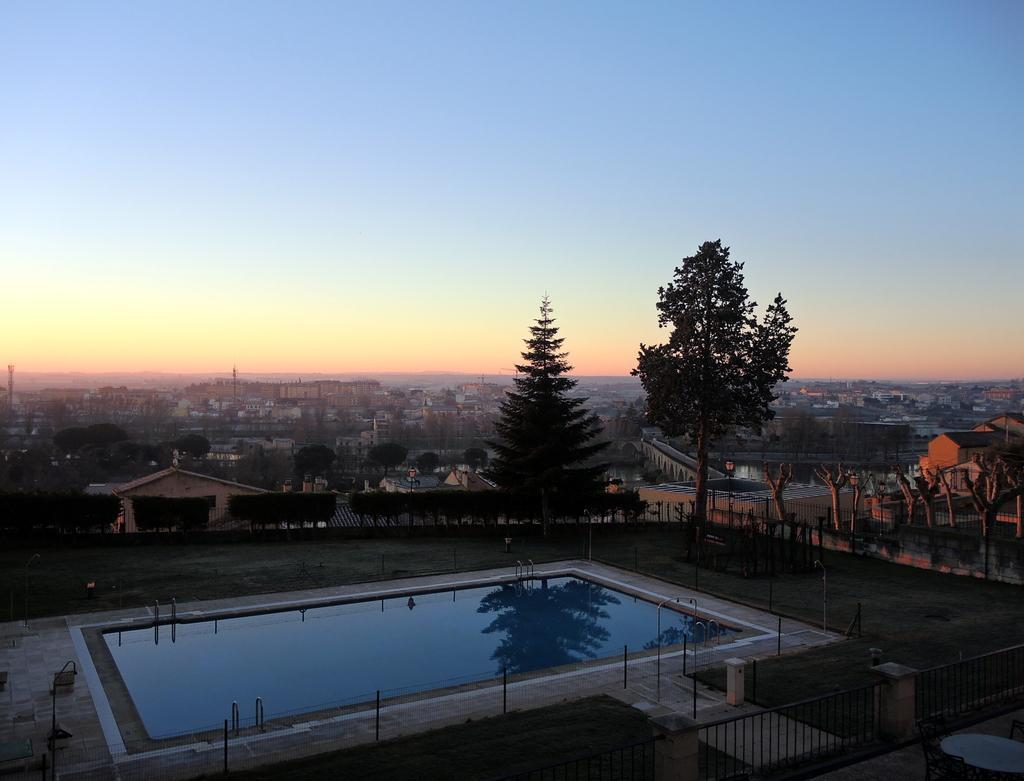Could you give a brief overview of what you see in this image? In the image there is a swimming pool and around the pool there are plants trees and buildings, there is a railing in the foreground of the image. 